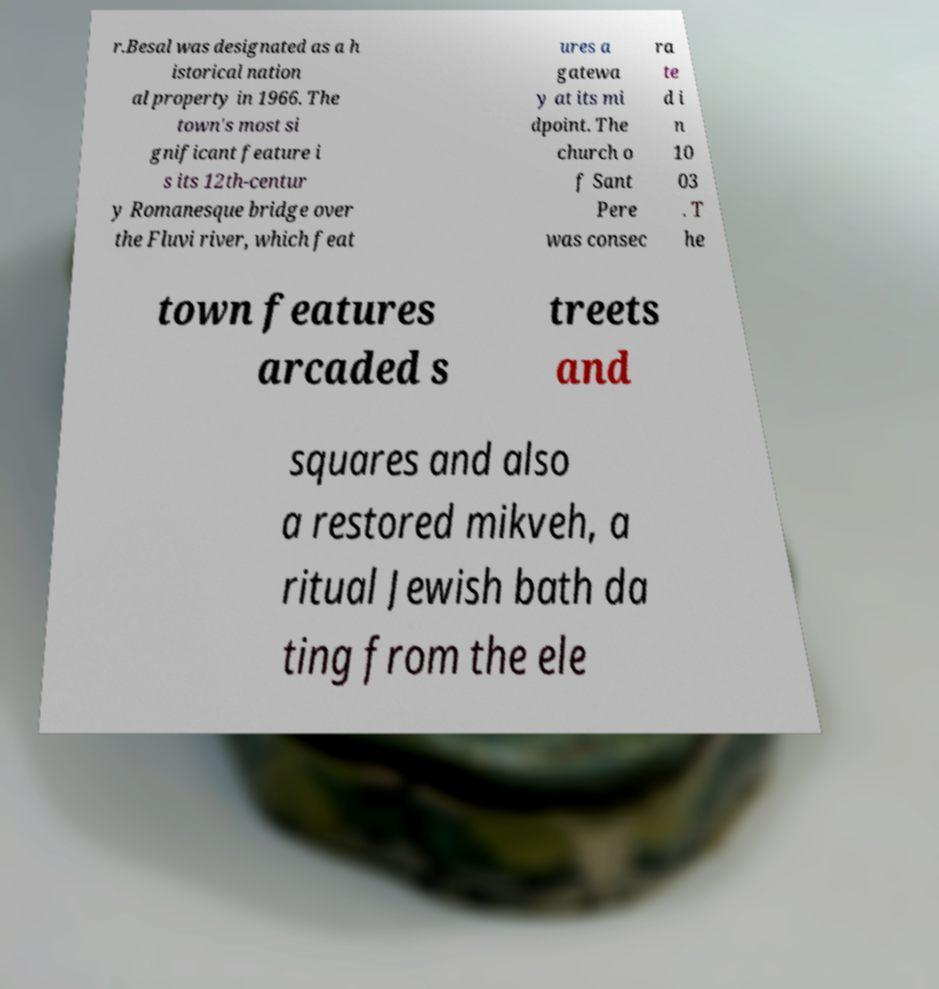Can you accurately transcribe the text from the provided image for me? r.Besal was designated as a h istorical nation al property in 1966. The town's most si gnificant feature i s its 12th-centur y Romanesque bridge over the Fluvi river, which feat ures a gatewa y at its mi dpoint. The church o f Sant Pere was consec ra te d i n 10 03 . T he town features arcaded s treets and squares and also a restored mikveh, a ritual Jewish bath da ting from the ele 